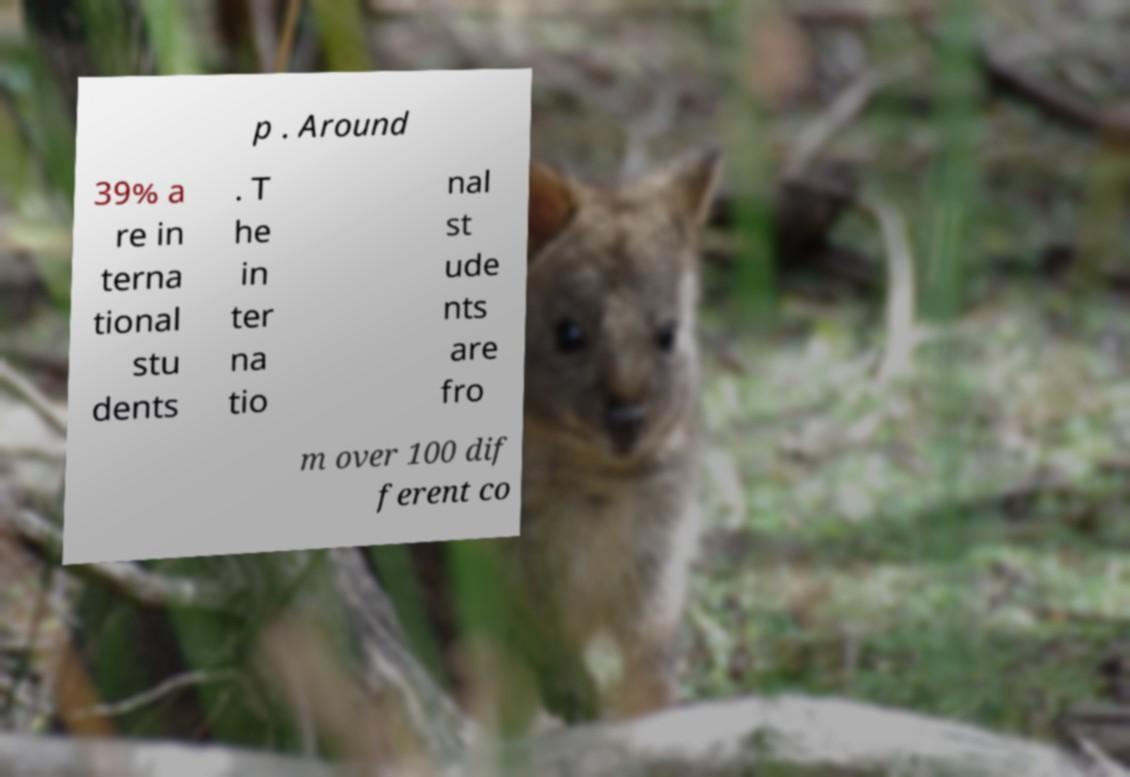What messages or text are displayed in this image? I need them in a readable, typed format. p . Around 39% a re in terna tional stu dents . T he in ter na tio nal st ude nts are fro m over 100 dif ferent co 